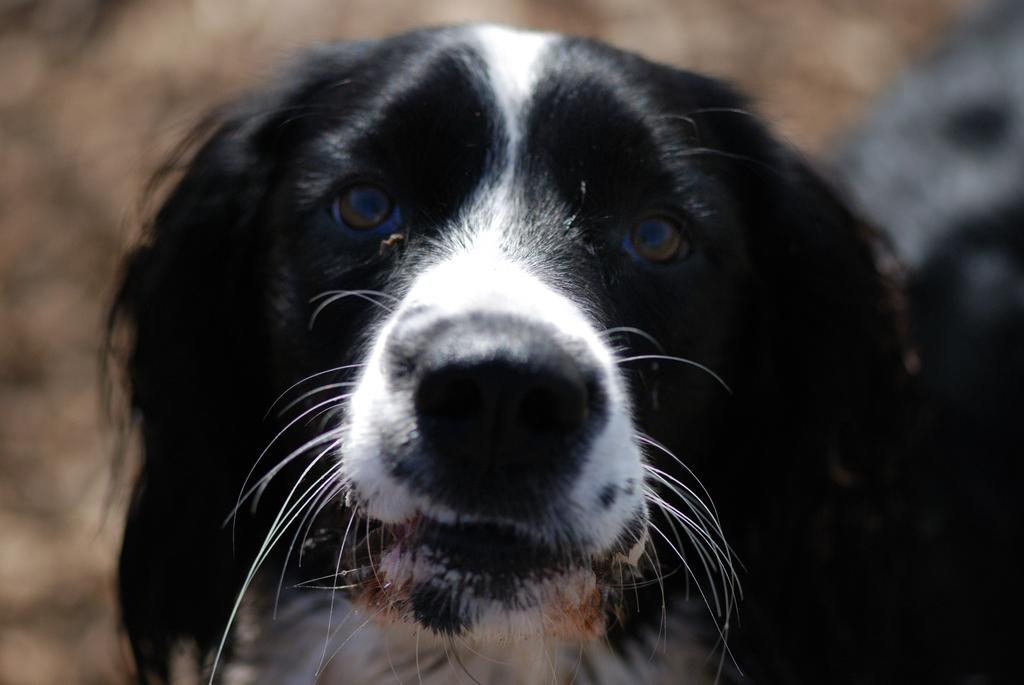What type of animal is in the image? There is a dog in the image. What colors can be seen on the dog? The dog is black and white in color. Can you describe the background of the image? The background of the image appears blurry. What gold object is being held by the dog in the image? There is no gold object present in the image, and the dog is not holding anything. What caption is written below the image? There is no caption present in the image; it is a photograph or illustration without text. 